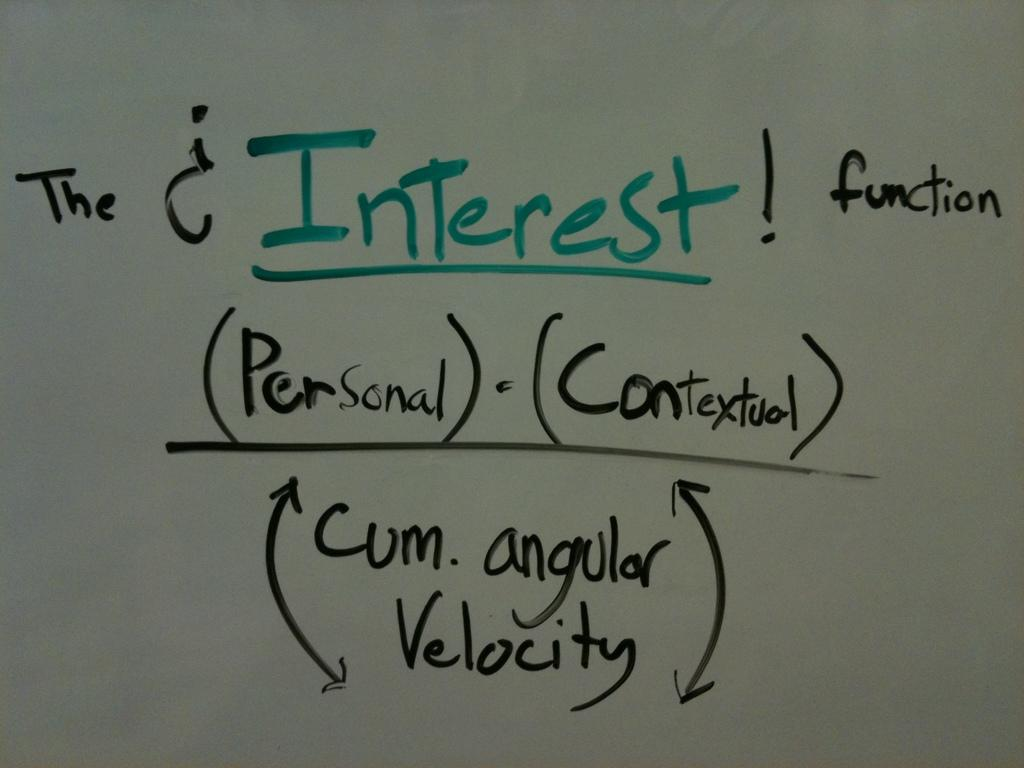<image>
Present a compact description of the photo's key features. The word "interest" is written in green along with some words in black text. 